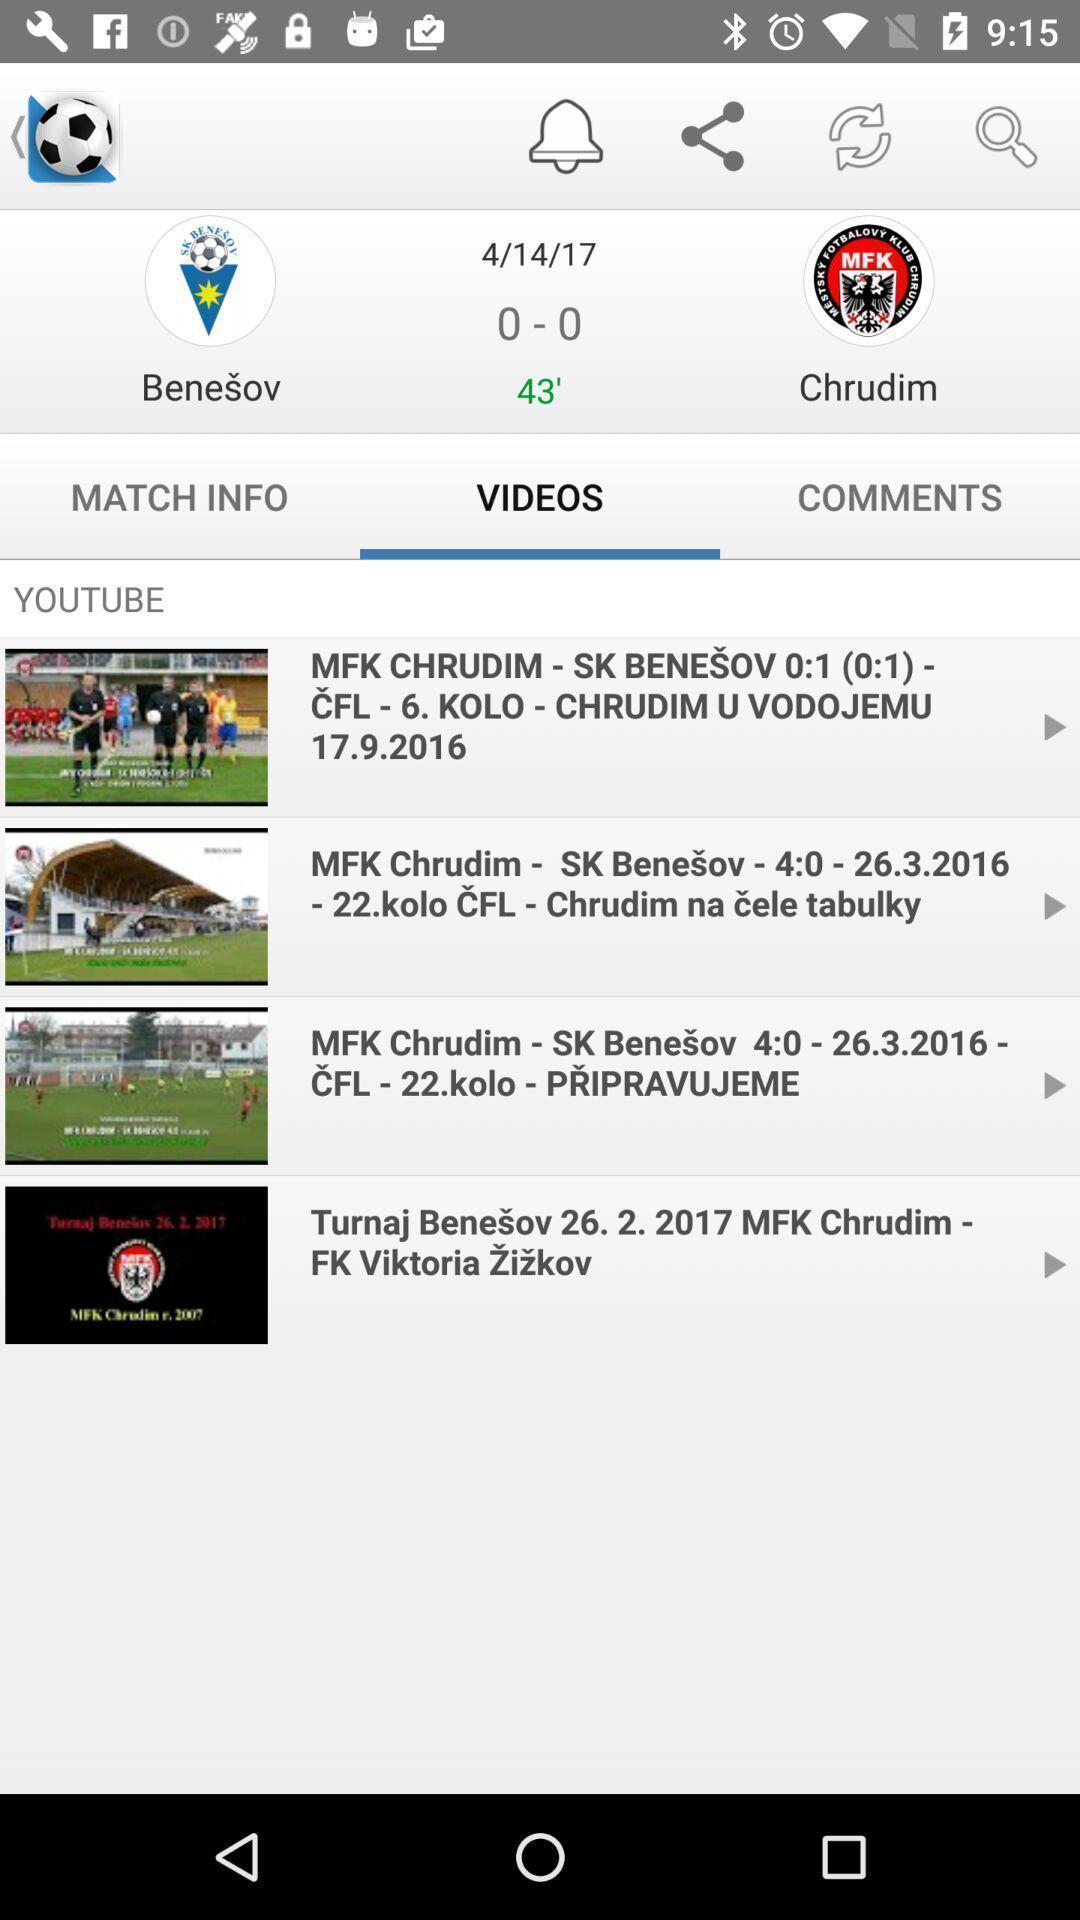Tell me what you see in this picture. Screen showing all the videos. 